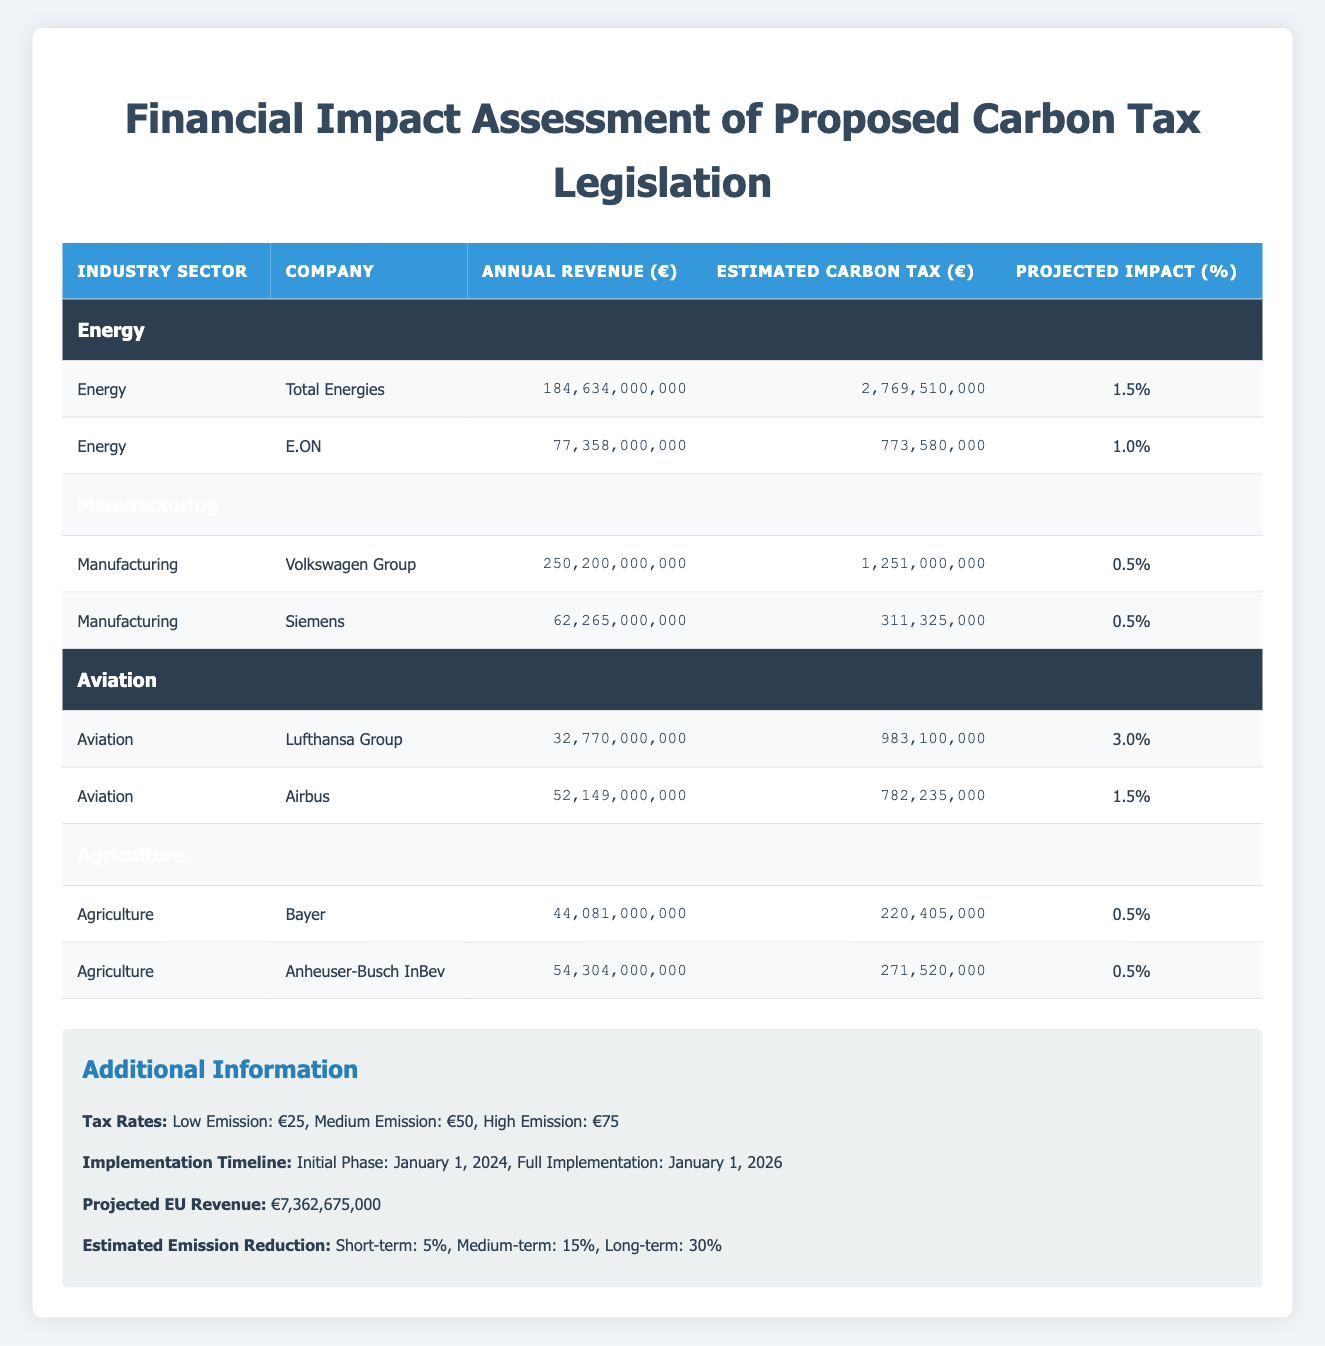What is the estimated carbon tax for Total Energies? The table lists the estimated carbon tax for Total Energies under the Energy sector, which is €2,769,510,000.
Answer: €2,769,510,000 Which company has the highest projected impact percentage? In the table, Lufthansa Group under the Aviation sector has the highest projected impact percentage at 3.0%.
Answer: 3.0% What is the combined annual revenue of the companies in the Manufacturing sector? The annual revenue for Volkswagen Group is €250,200,000,000 and for Siemens is €62,265,000,000. Adding these gives €250,200,000,000 + €62,265,000,000 = €312,465,000,000.
Answer: €312,465,000,000 Is the estimated carbon tax for Airbus greater than that for E.ON? Looking at the table, Airbus has an estimated carbon tax of €782,235,000 and E.ON has €773,580,000. Since €782,235,000 is greater than €773,580,000, the statement is true.
Answer: Yes What is the percentage increase in the estimated carbon tax from Bayer to Anheuser-Busch InBev? Bayer's estimated carbon tax is €220,405,000 and Anheuser-Busch InBev's is €271,520,000. The increase is €271,520,000 - €220,405,000 = €51,115,000. To find the percentage increase: (€51,115,000 / €220,405,000) * 100 = approximately 23.2%.
Answer: 23.2% What are the projected emissions reductions for the short term, medium term, and long term? The additional information section of the table lists the projected emission reductions as 5% for short term, 15% for medium term, and 30% for long term.
Answer: 5%, 15%, 30% Which sector has the lowest average projected impact percentage? To find the average projected impact percentage for each sector: Energy has (1.5 + 1.0) / 2 = 1.25%, Manufacturing has (0.5 + 0.5) / 2 = 0.5%, Aviation has (3.0 + 1.5) / 2 = 2.25%, and Agriculture has (0.5 + 0.5) / 2 = 0.5%. Both Manufacturing and Agriculture have the lowest average at 0.5%.
Answer: Manufacturing and Agriculture Are all companies in the Agriculture sector showing a projected impact percentage of 0.5%? The table lists both Bayer and Anheuser-Busch InBev in the Agriculture sector, and their projected impact percentages are both 0.5%. Therefore, the statement is true.
Answer: Yes 